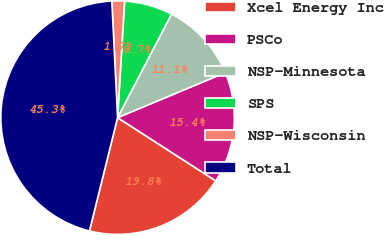Convert chart to OTSL. <chart><loc_0><loc_0><loc_500><loc_500><pie_chart><fcel>Xcel Energy Inc<fcel>PSCo<fcel>NSP-Minnesota<fcel>SPS<fcel>NSP-Wisconsin<fcel>Total<nl><fcel>19.77%<fcel>15.41%<fcel>11.05%<fcel>6.69%<fcel>1.74%<fcel>45.34%<nl></chart> 